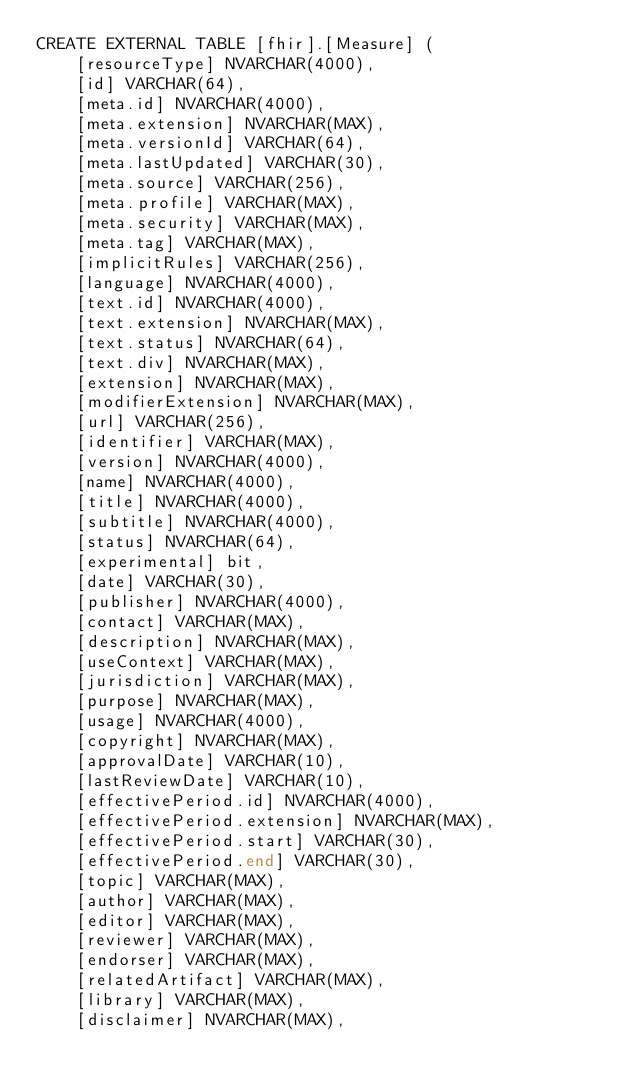Convert code to text. <code><loc_0><loc_0><loc_500><loc_500><_SQL_>CREATE EXTERNAL TABLE [fhir].[Measure] (
    [resourceType] NVARCHAR(4000),
    [id] VARCHAR(64),
    [meta.id] NVARCHAR(4000),
    [meta.extension] NVARCHAR(MAX),
    [meta.versionId] VARCHAR(64),
    [meta.lastUpdated] VARCHAR(30),
    [meta.source] VARCHAR(256),
    [meta.profile] VARCHAR(MAX),
    [meta.security] VARCHAR(MAX),
    [meta.tag] VARCHAR(MAX),
    [implicitRules] VARCHAR(256),
    [language] NVARCHAR(4000),
    [text.id] NVARCHAR(4000),
    [text.extension] NVARCHAR(MAX),
    [text.status] NVARCHAR(64),
    [text.div] NVARCHAR(MAX),
    [extension] NVARCHAR(MAX),
    [modifierExtension] NVARCHAR(MAX),
    [url] VARCHAR(256),
    [identifier] VARCHAR(MAX),
    [version] NVARCHAR(4000),
    [name] NVARCHAR(4000),
    [title] NVARCHAR(4000),
    [subtitle] NVARCHAR(4000),
    [status] NVARCHAR(64),
    [experimental] bit,
    [date] VARCHAR(30),
    [publisher] NVARCHAR(4000),
    [contact] VARCHAR(MAX),
    [description] NVARCHAR(MAX),
    [useContext] VARCHAR(MAX),
    [jurisdiction] VARCHAR(MAX),
    [purpose] NVARCHAR(MAX),
    [usage] NVARCHAR(4000),
    [copyright] NVARCHAR(MAX),
    [approvalDate] VARCHAR(10),
    [lastReviewDate] VARCHAR(10),
    [effectivePeriod.id] NVARCHAR(4000),
    [effectivePeriod.extension] NVARCHAR(MAX),
    [effectivePeriod.start] VARCHAR(30),
    [effectivePeriod.end] VARCHAR(30),
    [topic] VARCHAR(MAX),
    [author] VARCHAR(MAX),
    [editor] VARCHAR(MAX),
    [reviewer] VARCHAR(MAX),
    [endorser] VARCHAR(MAX),
    [relatedArtifact] VARCHAR(MAX),
    [library] VARCHAR(MAX),
    [disclaimer] NVARCHAR(MAX),</code> 